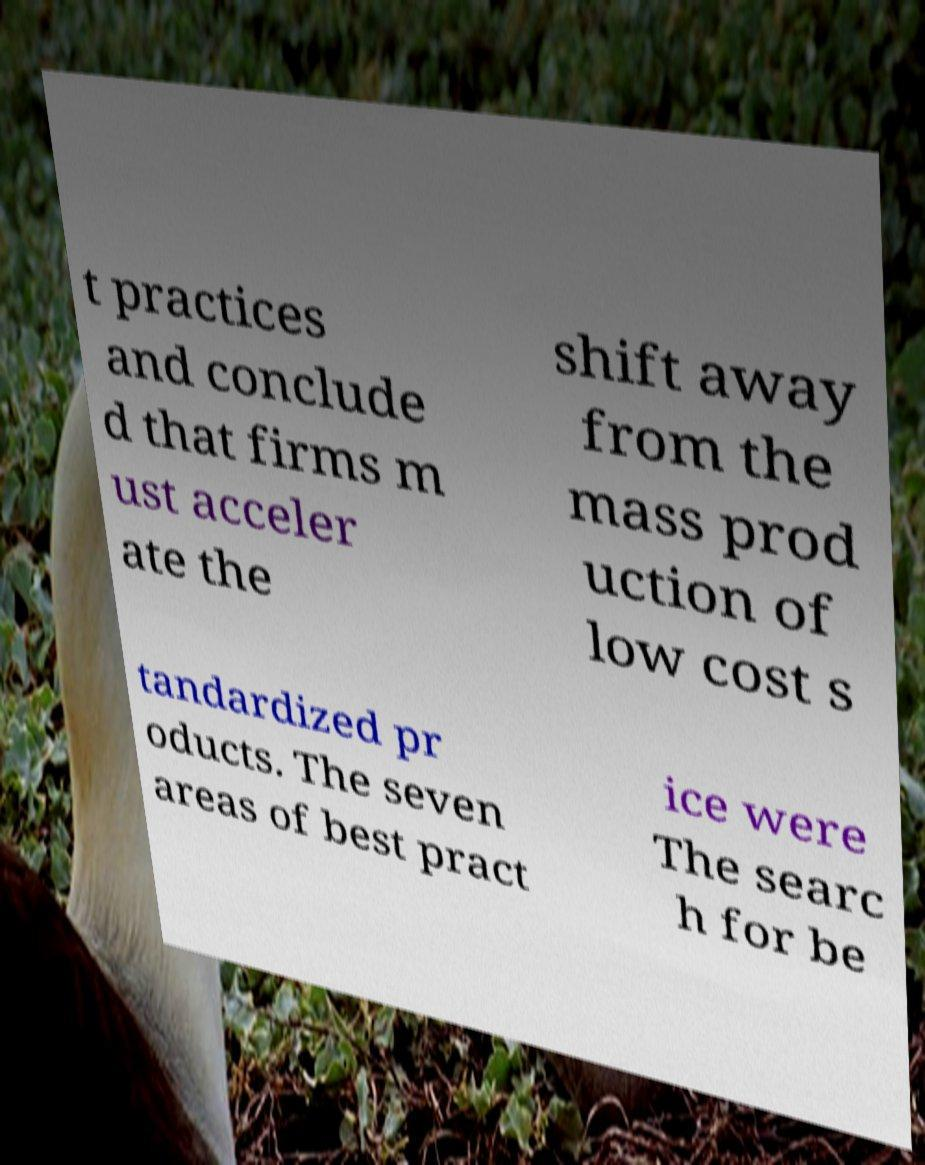Can you accurately transcribe the text from the provided image for me? t practices and conclude d that firms m ust acceler ate the shift away from the mass prod uction of low cost s tandardized pr oducts. The seven areas of best pract ice were The searc h for be 